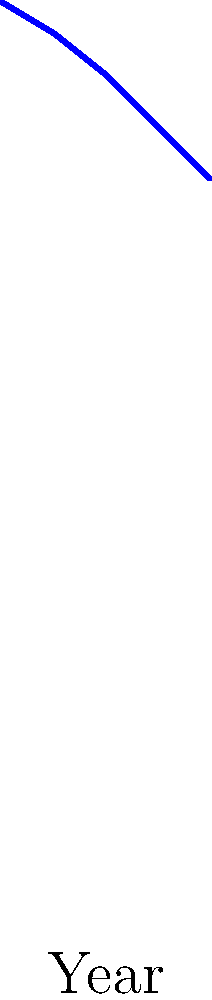Based on the satellite imagery analysis shown in the graph, what is the average rate of forest cover loss per year on the Omaha reservation between 2000 and 2020? To calculate the average rate of forest cover loss per year:

1. Calculate total forest cover loss:
   Forest cover in 2000: 85%
   Forest cover in 2020: 68%
   Total loss = 85% - 68% = 17%

2. Determine the time period:
   2020 - 2000 = 20 years

3. Calculate the average rate of loss per year:
   Average rate = Total loss / Number of years
   $\frac{17\%}{20 \text{ years}} = 0.85\%$ per year

Therefore, the average rate of forest cover loss per year on the Omaha reservation between 2000 and 2020 is 0.85% per year.
Answer: 0.85% per year 